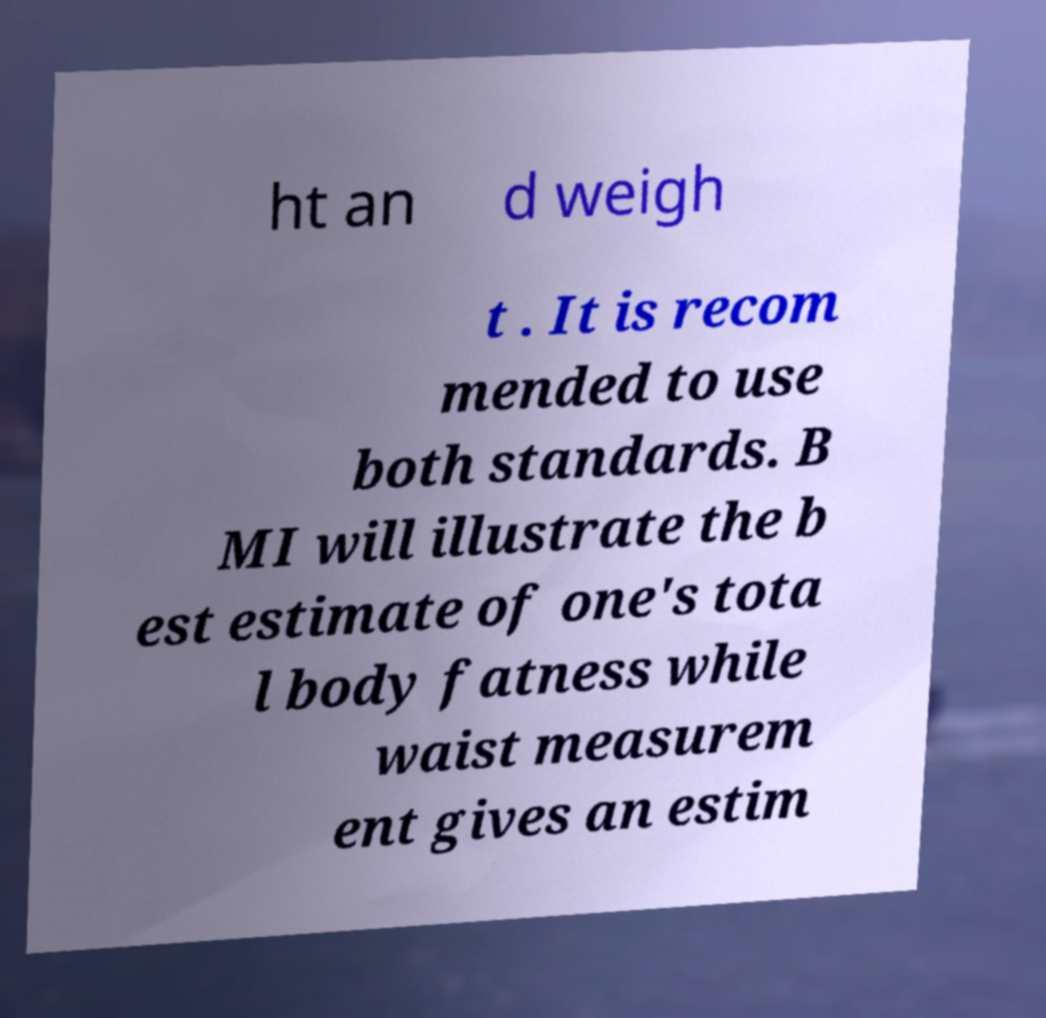Please read and relay the text visible in this image. What does it say? ht an d weigh t . It is recom mended to use both standards. B MI will illustrate the b est estimate of one's tota l body fatness while waist measurem ent gives an estim 